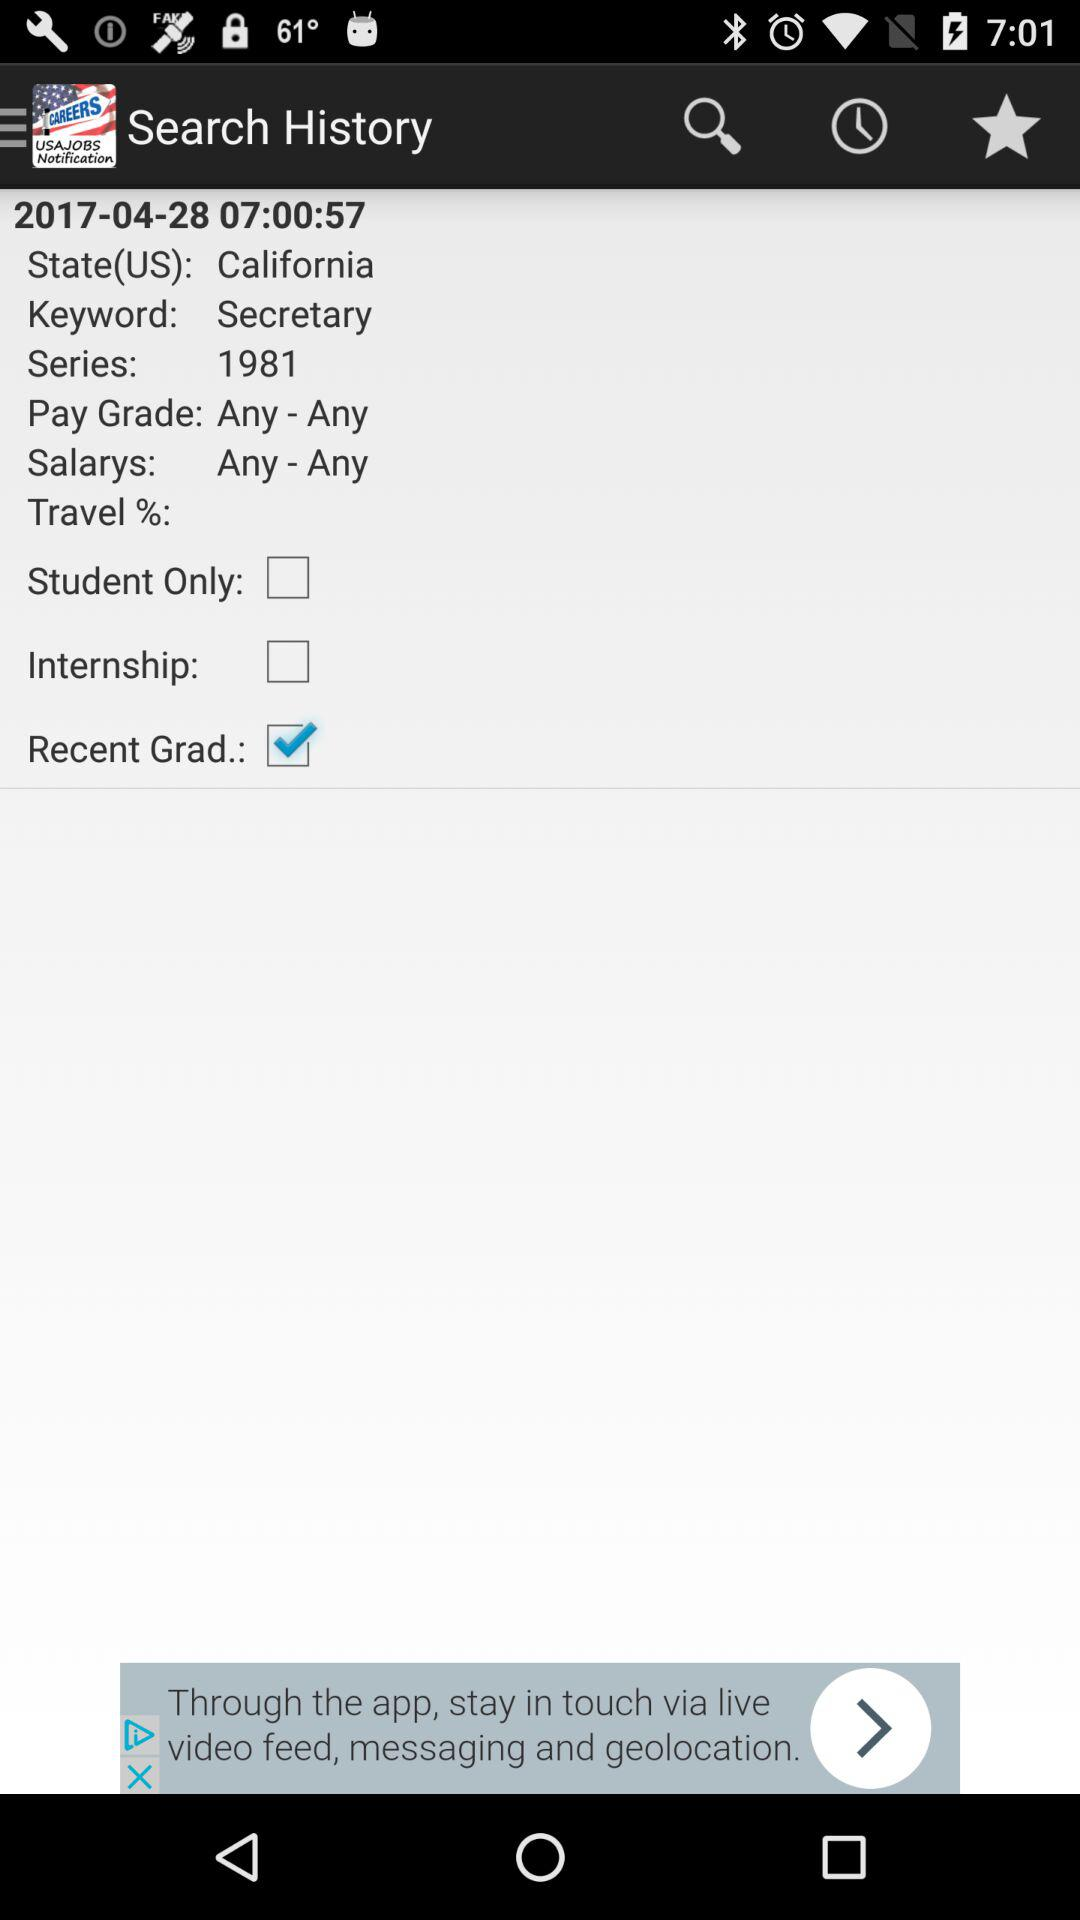What's the salary? The salary is "Any - Any". 